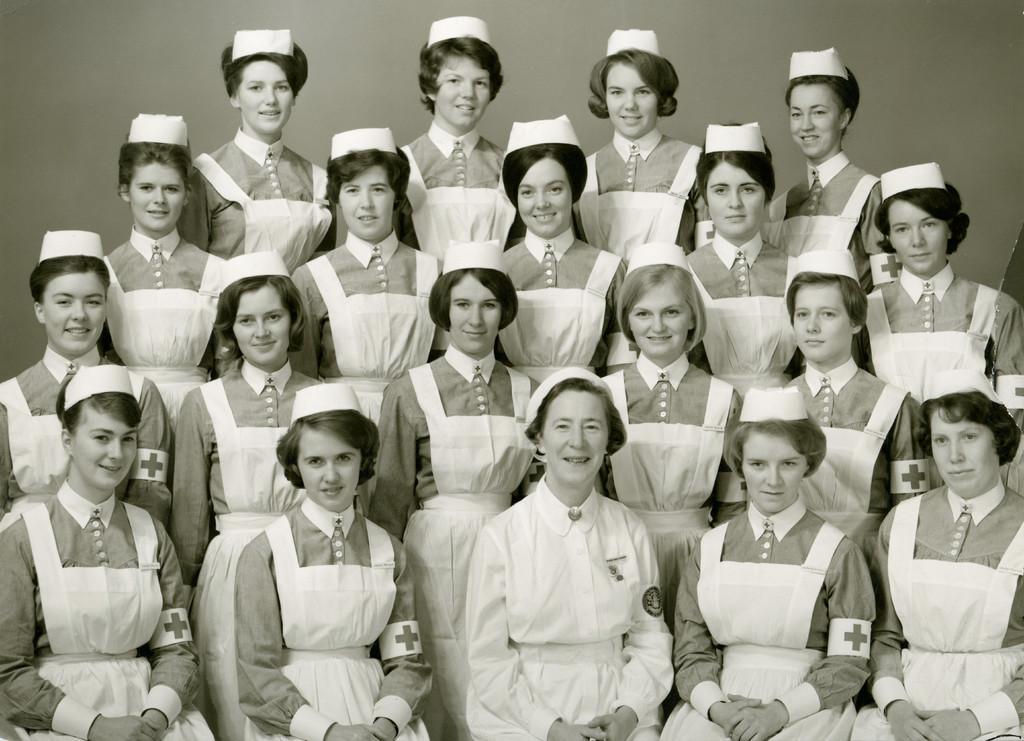Can you describe this image briefly? It is a black and white picture. In the center of the image, we can see a few people are sitting and few people are standing and they are smiling, which we can see on their faces. And they are wearing caps and they are in different costumes. In the background there is a wall. 